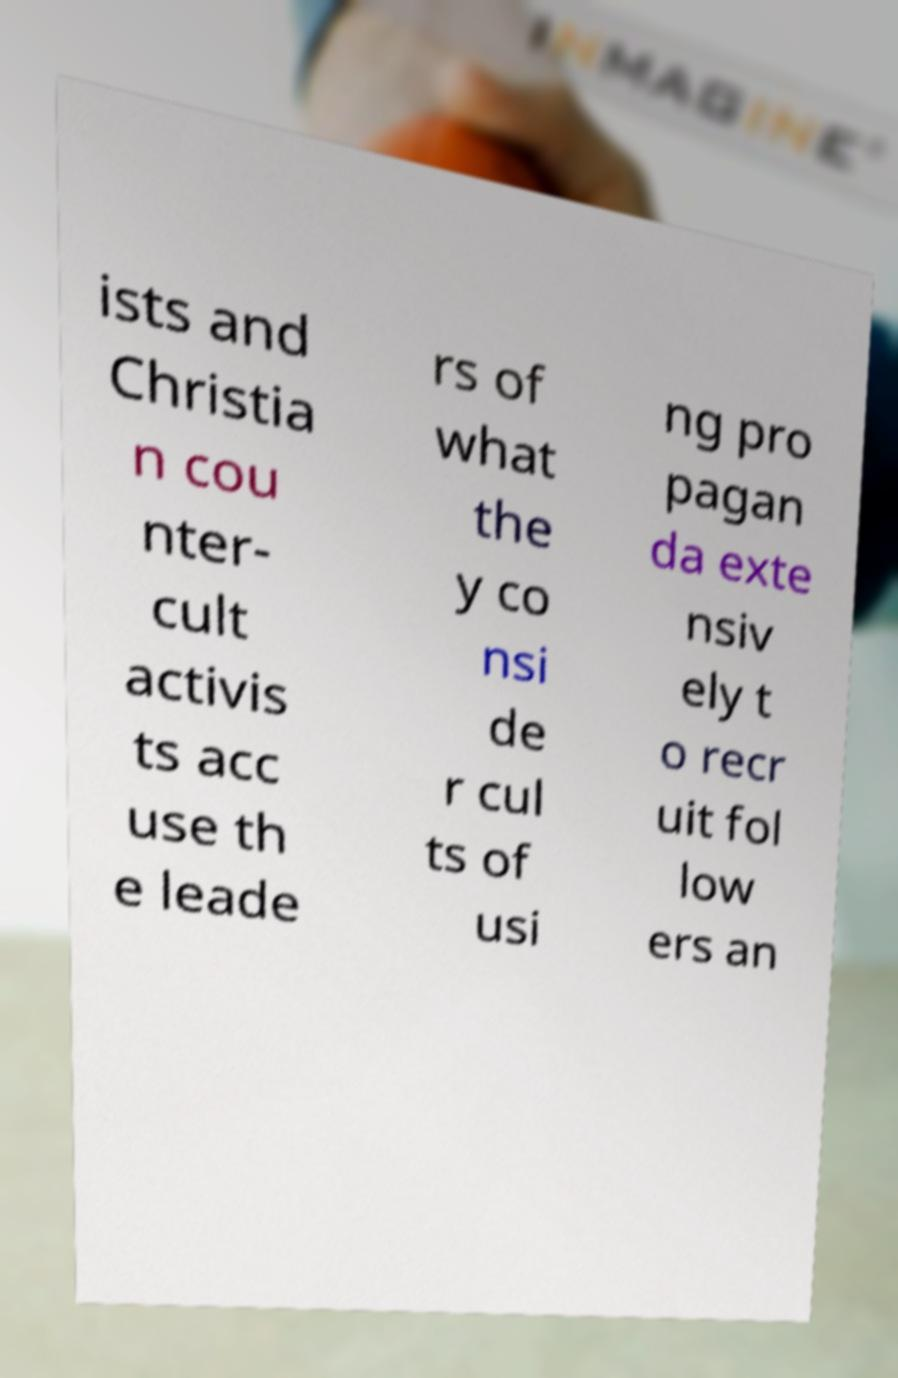I need the written content from this picture converted into text. Can you do that? ists and Christia n cou nter- cult activis ts acc use th e leade rs of what the y co nsi de r cul ts of usi ng pro pagan da exte nsiv ely t o recr uit fol low ers an 